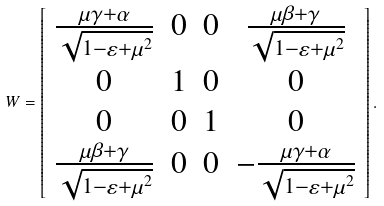Convert formula to latex. <formula><loc_0><loc_0><loc_500><loc_500>W = \left [ \begin{array} { c c c c } \frac { \mu \gamma + \alpha } { \sqrt { 1 - \varepsilon + \mu ^ { 2 } } } & 0 & 0 & \frac { \mu \beta + \gamma } { \sqrt { 1 - \varepsilon + \mu ^ { 2 } } } \\ 0 & 1 & 0 & 0 \\ 0 & 0 & 1 & 0 \\ \frac { \mu \beta + \gamma } { \sqrt { 1 - \varepsilon + \mu ^ { 2 } } } & 0 & 0 & - \frac { \mu \gamma + \alpha } { \sqrt { 1 - \varepsilon + \mu ^ { 2 } } } \end{array} \right ] .</formula> 